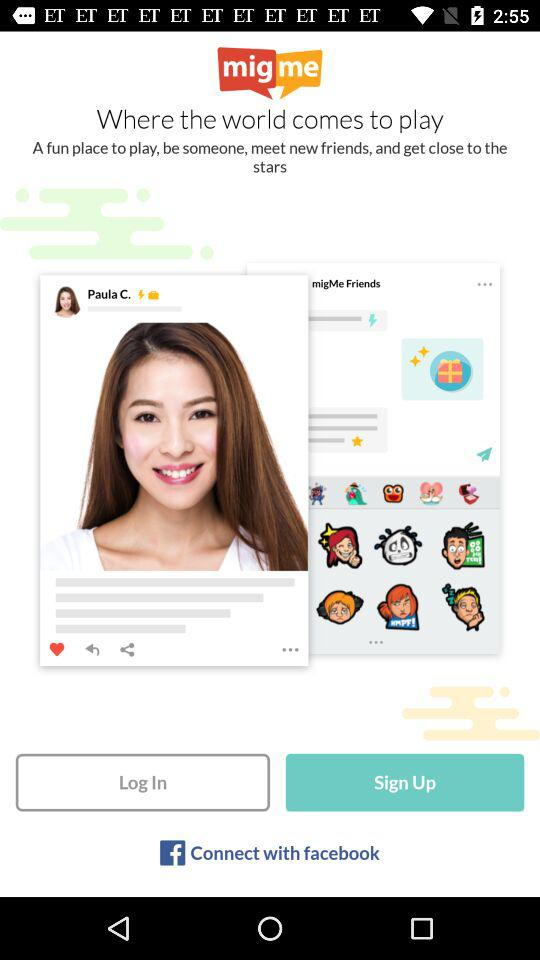Through which application can we connect? You can connect with "facebook". 